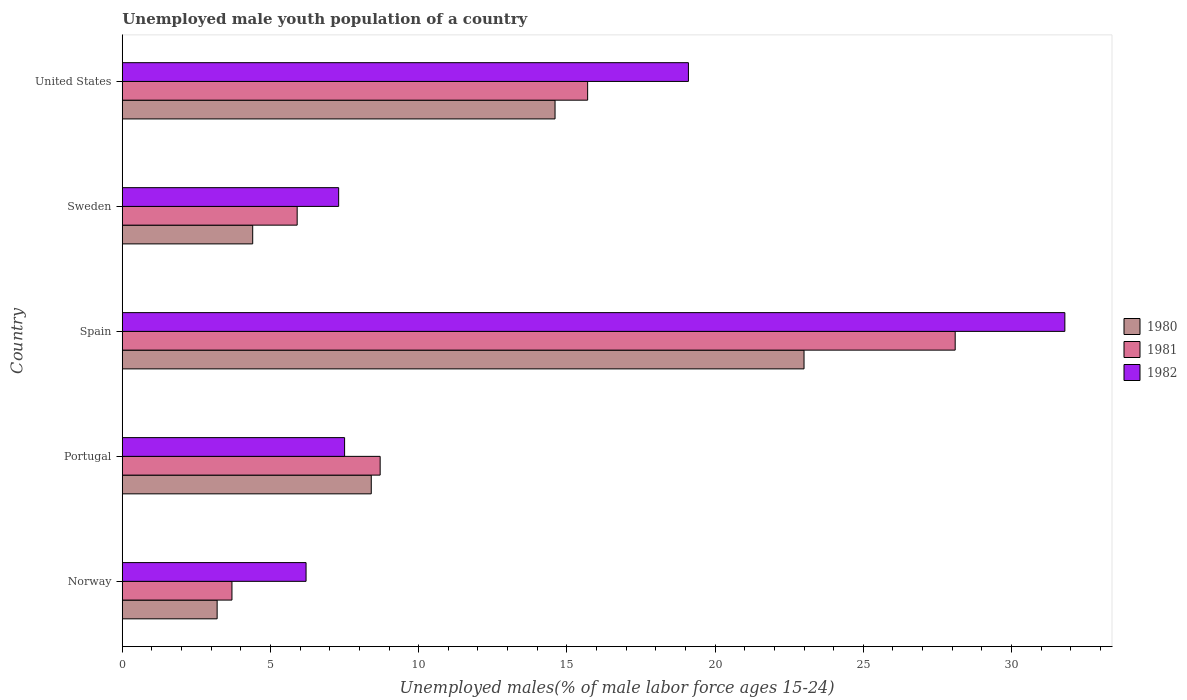How many different coloured bars are there?
Your answer should be compact. 3. Are the number of bars per tick equal to the number of legend labels?
Keep it short and to the point. Yes. Are the number of bars on each tick of the Y-axis equal?
Offer a terse response. Yes. How many bars are there on the 4th tick from the bottom?
Offer a terse response. 3. What is the label of the 5th group of bars from the top?
Give a very brief answer. Norway. In how many cases, is the number of bars for a given country not equal to the number of legend labels?
Your response must be concise. 0. What is the percentage of unemployed male youth population in 1982 in Sweden?
Make the answer very short. 7.3. Across all countries, what is the maximum percentage of unemployed male youth population in 1982?
Provide a short and direct response. 31.8. Across all countries, what is the minimum percentage of unemployed male youth population in 1982?
Your response must be concise. 6.2. In which country was the percentage of unemployed male youth population in 1980 minimum?
Your response must be concise. Norway. What is the total percentage of unemployed male youth population in 1981 in the graph?
Your answer should be very brief. 62.1. What is the difference between the percentage of unemployed male youth population in 1980 in Portugal and that in Sweden?
Provide a short and direct response. 4. What is the difference between the percentage of unemployed male youth population in 1982 in United States and the percentage of unemployed male youth population in 1981 in Portugal?
Ensure brevity in your answer.  10.4. What is the average percentage of unemployed male youth population in 1982 per country?
Provide a succinct answer. 14.38. What is the difference between the percentage of unemployed male youth population in 1982 and percentage of unemployed male youth population in 1981 in Spain?
Offer a very short reply. 3.7. What is the ratio of the percentage of unemployed male youth population in 1981 in Norway to that in Portugal?
Offer a terse response. 0.43. Is the difference between the percentage of unemployed male youth population in 1982 in Portugal and Spain greater than the difference between the percentage of unemployed male youth population in 1981 in Portugal and Spain?
Offer a very short reply. No. What is the difference between the highest and the second highest percentage of unemployed male youth population in 1981?
Keep it short and to the point. 12.4. What is the difference between the highest and the lowest percentage of unemployed male youth population in 1980?
Offer a very short reply. 19.8. In how many countries, is the percentage of unemployed male youth population in 1981 greater than the average percentage of unemployed male youth population in 1981 taken over all countries?
Your response must be concise. 2. Is the sum of the percentage of unemployed male youth population in 1981 in Spain and United States greater than the maximum percentage of unemployed male youth population in 1980 across all countries?
Ensure brevity in your answer.  Yes. What does the 3rd bar from the bottom in United States represents?
Ensure brevity in your answer.  1982. How many bars are there?
Your response must be concise. 15. How many countries are there in the graph?
Provide a short and direct response. 5. Are the values on the major ticks of X-axis written in scientific E-notation?
Offer a very short reply. No. Where does the legend appear in the graph?
Ensure brevity in your answer.  Center right. How are the legend labels stacked?
Offer a terse response. Vertical. What is the title of the graph?
Your answer should be very brief. Unemployed male youth population of a country. What is the label or title of the X-axis?
Provide a short and direct response. Unemployed males(% of male labor force ages 15-24). What is the Unemployed males(% of male labor force ages 15-24) of 1980 in Norway?
Offer a very short reply. 3.2. What is the Unemployed males(% of male labor force ages 15-24) of 1981 in Norway?
Your answer should be very brief. 3.7. What is the Unemployed males(% of male labor force ages 15-24) in 1982 in Norway?
Your answer should be very brief. 6.2. What is the Unemployed males(% of male labor force ages 15-24) of 1980 in Portugal?
Provide a succinct answer. 8.4. What is the Unemployed males(% of male labor force ages 15-24) in 1981 in Portugal?
Give a very brief answer. 8.7. What is the Unemployed males(% of male labor force ages 15-24) of 1981 in Spain?
Your response must be concise. 28.1. What is the Unemployed males(% of male labor force ages 15-24) of 1982 in Spain?
Your answer should be compact. 31.8. What is the Unemployed males(% of male labor force ages 15-24) of 1980 in Sweden?
Ensure brevity in your answer.  4.4. What is the Unemployed males(% of male labor force ages 15-24) of 1981 in Sweden?
Offer a very short reply. 5.9. What is the Unemployed males(% of male labor force ages 15-24) of 1982 in Sweden?
Provide a short and direct response. 7.3. What is the Unemployed males(% of male labor force ages 15-24) of 1980 in United States?
Provide a succinct answer. 14.6. What is the Unemployed males(% of male labor force ages 15-24) of 1981 in United States?
Offer a terse response. 15.7. What is the Unemployed males(% of male labor force ages 15-24) of 1982 in United States?
Give a very brief answer. 19.1. Across all countries, what is the maximum Unemployed males(% of male labor force ages 15-24) of 1980?
Keep it short and to the point. 23. Across all countries, what is the maximum Unemployed males(% of male labor force ages 15-24) in 1981?
Keep it short and to the point. 28.1. Across all countries, what is the maximum Unemployed males(% of male labor force ages 15-24) in 1982?
Your answer should be compact. 31.8. Across all countries, what is the minimum Unemployed males(% of male labor force ages 15-24) in 1980?
Give a very brief answer. 3.2. Across all countries, what is the minimum Unemployed males(% of male labor force ages 15-24) of 1981?
Provide a short and direct response. 3.7. Across all countries, what is the minimum Unemployed males(% of male labor force ages 15-24) of 1982?
Give a very brief answer. 6.2. What is the total Unemployed males(% of male labor force ages 15-24) in 1980 in the graph?
Provide a short and direct response. 53.6. What is the total Unemployed males(% of male labor force ages 15-24) in 1981 in the graph?
Your answer should be very brief. 62.1. What is the total Unemployed males(% of male labor force ages 15-24) in 1982 in the graph?
Provide a short and direct response. 71.9. What is the difference between the Unemployed males(% of male labor force ages 15-24) in 1981 in Norway and that in Portugal?
Give a very brief answer. -5. What is the difference between the Unemployed males(% of male labor force ages 15-24) in 1980 in Norway and that in Spain?
Provide a succinct answer. -19.8. What is the difference between the Unemployed males(% of male labor force ages 15-24) in 1981 in Norway and that in Spain?
Provide a succinct answer. -24.4. What is the difference between the Unemployed males(% of male labor force ages 15-24) in 1982 in Norway and that in Spain?
Offer a very short reply. -25.6. What is the difference between the Unemployed males(% of male labor force ages 15-24) in 1981 in Norway and that in Sweden?
Your answer should be compact. -2.2. What is the difference between the Unemployed males(% of male labor force ages 15-24) of 1980 in Norway and that in United States?
Keep it short and to the point. -11.4. What is the difference between the Unemployed males(% of male labor force ages 15-24) of 1981 in Norway and that in United States?
Offer a terse response. -12. What is the difference between the Unemployed males(% of male labor force ages 15-24) of 1982 in Norway and that in United States?
Offer a terse response. -12.9. What is the difference between the Unemployed males(% of male labor force ages 15-24) of 1980 in Portugal and that in Spain?
Give a very brief answer. -14.6. What is the difference between the Unemployed males(% of male labor force ages 15-24) of 1981 in Portugal and that in Spain?
Offer a very short reply. -19.4. What is the difference between the Unemployed males(% of male labor force ages 15-24) of 1982 in Portugal and that in Spain?
Offer a very short reply. -24.3. What is the difference between the Unemployed males(% of male labor force ages 15-24) of 1980 in Portugal and that in Sweden?
Keep it short and to the point. 4. What is the difference between the Unemployed males(% of male labor force ages 15-24) of 1982 in Portugal and that in Sweden?
Make the answer very short. 0.2. What is the difference between the Unemployed males(% of male labor force ages 15-24) in 1980 in Portugal and that in United States?
Your answer should be compact. -6.2. What is the difference between the Unemployed males(% of male labor force ages 15-24) in 1981 in Portugal and that in United States?
Give a very brief answer. -7. What is the difference between the Unemployed males(% of male labor force ages 15-24) of 1980 in Spain and that in Sweden?
Give a very brief answer. 18.6. What is the difference between the Unemployed males(% of male labor force ages 15-24) of 1981 in Spain and that in Sweden?
Provide a succinct answer. 22.2. What is the difference between the Unemployed males(% of male labor force ages 15-24) of 1982 in Spain and that in Sweden?
Give a very brief answer. 24.5. What is the difference between the Unemployed males(% of male labor force ages 15-24) in 1980 in Spain and that in United States?
Ensure brevity in your answer.  8.4. What is the difference between the Unemployed males(% of male labor force ages 15-24) in 1982 in Spain and that in United States?
Provide a short and direct response. 12.7. What is the difference between the Unemployed males(% of male labor force ages 15-24) in 1980 in Sweden and that in United States?
Make the answer very short. -10.2. What is the difference between the Unemployed males(% of male labor force ages 15-24) of 1981 in Sweden and that in United States?
Your answer should be very brief. -9.8. What is the difference between the Unemployed males(% of male labor force ages 15-24) in 1980 in Norway and the Unemployed males(% of male labor force ages 15-24) in 1981 in Portugal?
Provide a short and direct response. -5.5. What is the difference between the Unemployed males(% of male labor force ages 15-24) in 1980 in Norway and the Unemployed males(% of male labor force ages 15-24) in 1981 in Spain?
Keep it short and to the point. -24.9. What is the difference between the Unemployed males(% of male labor force ages 15-24) in 1980 in Norway and the Unemployed males(% of male labor force ages 15-24) in 1982 in Spain?
Your answer should be compact. -28.6. What is the difference between the Unemployed males(% of male labor force ages 15-24) in 1981 in Norway and the Unemployed males(% of male labor force ages 15-24) in 1982 in Spain?
Make the answer very short. -28.1. What is the difference between the Unemployed males(% of male labor force ages 15-24) of 1981 in Norway and the Unemployed males(% of male labor force ages 15-24) of 1982 in Sweden?
Your response must be concise. -3.6. What is the difference between the Unemployed males(% of male labor force ages 15-24) of 1980 in Norway and the Unemployed males(% of male labor force ages 15-24) of 1981 in United States?
Provide a short and direct response. -12.5. What is the difference between the Unemployed males(% of male labor force ages 15-24) of 1980 in Norway and the Unemployed males(% of male labor force ages 15-24) of 1982 in United States?
Ensure brevity in your answer.  -15.9. What is the difference between the Unemployed males(% of male labor force ages 15-24) of 1981 in Norway and the Unemployed males(% of male labor force ages 15-24) of 1982 in United States?
Ensure brevity in your answer.  -15.4. What is the difference between the Unemployed males(% of male labor force ages 15-24) of 1980 in Portugal and the Unemployed males(% of male labor force ages 15-24) of 1981 in Spain?
Offer a terse response. -19.7. What is the difference between the Unemployed males(% of male labor force ages 15-24) in 1980 in Portugal and the Unemployed males(% of male labor force ages 15-24) in 1982 in Spain?
Offer a very short reply. -23.4. What is the difference between the Unemployed males(% of male labor force ages 15-24) of 1981 in Portugal and the Unemployed males(% of male labor force ages 15-24) of 1982 in Spain?
Offer a very short reply. -23.1. What is the difference between the Unemployed males(% of male labor force ages 15-24) of 1980 in Portugal and the Unemployed males(% of male labor force ages 15-24) of 1981 in Sweden?
Give a very brief answer. 2.5. What is the difference between the Unemployed males(% of male labor force ages 15-24) of 1981 in Portugal and the Unemployed males(% of male labor force ages 15-24) of 1982 in Sweden?
Offer a terse response. 1.4. What is the difference between the Unemployed males(% of male labor force ages 15-24) of 1980 in Portugal and the Unemployed males(% of male labor force ages 15-24) of 1981 in United States?
Offer a very short reply. -7.3. What is the difference between the Unemployed males(% of male labor force ages 15-24) of 1981 in Portugal and the Unemployed males(% of male labor force ages 15-24) of 1982 in United States?
Ensure brevity in your answer.  -10.4. What is the difference between the Unemployed males(% of male labor force ages 15-24) in 1981 in Spain and the Unemployed males(% of male labor force ages 15-24) in 1982 in Sweden?
Your response must be concise. 20.8. What is the difference between the Unemployed males(% of male labor force ages 15-24) in 1980 in Spain and the Unemployed males(% of male labor force ages 15-24) in 1982 in United States?
Your response must be concise. 3.9. What is the difference between the Unemployed males(% of male labor force ages 15-24) in 1981 in Spain and the Unemployed males(% of male labor force ages 15-24) in 1982 in United States?
Make the answer very short. 9. What is the difference between the Unemployed males(% of male labor force ages 15-24) in 1980 in Sweden and the Unemployed males(% of male labor force ages 15-24) in 1982 in United States?
Your answer should be very brief. -14.7. What is the difference between the Unemployed males(% of male labor force ages 15-24) of 1981 in Sweden and the Unemployed males(% of male labor force ages 15-24) of 1982 in United States?
Your answer should be compact. -13.2. What is the average Unemployed males(% of male labor force ages 15-24) of 1980 per country?
Provide a short and direct response. 10.72. What is the average Unemployed males(% of male labor force ages 15-24) of 1981 per country?
Your answer should be very brief. 12.42. What is the average Unemployed males(% of male labor force ages 15-24) of 1982 per country?
Provide a succinct answer. 14.38. What is the difference between the Unemployed males(% of male labor force ages 15-24) in 1981 and Unemployed males(% of male labor force ages 15-24) in 1982 in Norway?
Ensure brevity in your answer.  -2.5. What is the difference between the Unemployed males(% of male labor force ages 15-24) of 1980 and Unemployed males(% of male labor force ages 15-24) of 1981 in Portugal?
Provide a short and direct response. -0.3. What is the difference between the Unemployed males(% of male labor force ages 15-24) in 1980 and Unemployed males(% of male labor force ages 15-24) in 1982 in Portugal?
Your answer should be compact. 0.9. What is the difference between the Unemployed males(% of male labor force ages 15-24) of 1980 and Unemployed males(% of male labor force ages 15-24) of 1981 in Sweden?
Your response must be concise. -1.5. What is the difference between the Unemployed males(% of male labor force ages 15-24) of 1980 and Unemployed males(% of male labor force ages 15-24) of 1982 in Sweden?
Provide a short and direct response. -2.9. What is the difference between the Unemployed males(% of male labor force ages 15-24) of 1981 and Unemployed males(% of male labor force ages 15-24) of 1982 in United States?
Your answer should be very brief. -3.4. What is the ratio of the Unemployed males(% of male labor force ages 15-24) in 1980 in Norway to that in Portugal?
Ensure brevity in your answer.  0.38. What is the ratio of the Unemployed males(% of male labor force ages 15-24) in 1981 in Norway to that in Portugal?
Provide a short and direct response. 0.43. What is the ratio of the Unemployed males(% of male labor force ages 15-24) in 1982 in Norway to that in Portugal?
Offer a very short reply. 0.83. What is the ratio of the Unemployed males(% of male labor force ages 15-24) in 1980 in Norway to that in Spain?
Offer a terse response. 0.14. What is the ratio of the Unemployed males(% of male labor force ages 15-24) in 1981 in Norway to that in Spain?
Keep it short and to the point. 0.13. What is the ratio of the Unemployed males(% of male labor force ages 15-24) of 1982 in Norway to that in Spain?
Your response must be concise. 0.2. What is the ratio of the Unemployed males(% of male labor force ages 15-24) of 1980 in Norway to that in Sweden?
Your response must be concise. 0.73. What is the ratio of the Unemployed males(% of male labor force ages 15-24) in 1981 in Norway to that in Sweden?
Make the answer very short. 0.63. What is the ratio of the Unemployed males(% of male labor force ages 15-24) in 1982 in Norway to that in Sweden?
Ensure brevity in your answer.  0.85. What is the ratio of the Unemployed males(% of male labor force ages 15-24) of 1980 in Norway to that in United States?
Your answer should be compact. 0.22. What is the ratio of the Unemployed males(% of male labor force ages 15-24) of 1981 in Norway to that in United States?
Keep it short and to the point. 0.24. What is the ratio of the Unemployed males(% of male labor force ages 15-24) of 1982 in Norway to that in United States?
Keep it short and to the point. 0.32. What is the ratio of the Unemployed males(% of male labor force ages 15-24) in 1980 in Portugal to that in Spain?
Provide a short and direct response. 0.37. What is the ratio of the Unemployed males(% of male labor force ages 15-24) of 1981 in Portugal to that in Spain?
Give a very brief answer. 0.31. What is the ratio of the Unemployed males(% of male labor force ages 15-24) of 1982 in Portugal to that in Spain?
Offer a very short reply. 0.24. What is the ratio of the Unemployed males(% of male labor force ages 15-24) of 1980 in Portugal to that in Sweden?
Keep it short and to the point. 1.91. What is the ratio of the Unemployed males(% of male labor force ages 15-24) in 1981 in Portugal to that in Sweden?
Keep it short and to the point. 1.47. What is the ratio of the Unemployed males(% of male labor force ages 15-24) of 1982 in Portugal to that in Sweden?
Make the answer very short. 1.03. What is the ratio of the Unemployed males(% of male labor force ages 15-24) in 1980 in Portugal to that in United States?
Provide a succinct answer. 0.58. What is the ratio of the Unemployed males(% of male labor force ages 15-24) of 1981 in Portugal to that in United States?
Offer a terse response. 0.55. What is the ratio of the Unemployed males(% of male labor force ages 15-24) in 1982 in Portugal to that in United States?
Offer a very short reply. 0.39. What is the ratio of the Unemployed males(% of male labor force ages 15-24) in 1980 in Spain to that in Sweden?
Offer a terse response. 5.23. What is the ratio of the Unemployed males(% of male labor force ages 15-24) in 1981 in Spain to that in Sweden?
Offer a very short reply. 4.76. What is the ratio of the Unemployed males(% of male labor force ages 15-24) of 1982 in Spain to that in Sweden?
Ensure brevity in your answer.  4.36. What is the ratio of the Unemployed males(% of male labor force ages 15-24) in 1980 in Spain to that in United States?
Ensure brevity in your answer.  1.58. What is the ratio of the Unemployed males(% of male labor force ages 15-24) of 1981 in Spain to that in United States?
Offer a very short reply. 1.79. What is the ratio of the Unemployed males(% of male labor force ages 15-24) of 1982 in Spain to that in United States?
Keep it short and to the point. 1.66. What is the ratio of the Unemployed males(% of male labor force ages 15-24) in 1980 in Sweden to that in United States?
Your answer should be compact. 0.3. What is the ratio of the Unemployed males(% of male labor force ages 15-24) of 1981 in Sweden to that in United States?
Ensure brevity in your answer.  0.38. What is the ratio of the Unemployed males(% of male labor force ages 15-24) of 1982 in Sweden to that in United States?
Provide a short and direct response. 0.38. What is the difference between the highest and the second highest Unemployed males(% of male labor force ages 15-24) in 1982?
Your answer should be very brief. 12.7. What is the difference between the highest and the lowest Unemployed males(% of male labor force ages 15-24) of 1980?
Give a very brief answer. 19.8. What is the difference between the highest and the lowest Unemployed males(% of male labor force ages 15-24) in 1981?
Provide a succinct answer. 24.4. What is the difference between the highest and the lowest Unemployed males(% of male labor force ages 15-24) in 1982?
Your response must be concise. 25.6. 